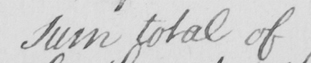What text is written in this handwritten line? sum total of 